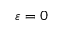<formula> <loc_0><loc_0><loc_500><loc_500>\varepsilon = 0</formula> 